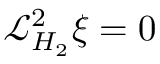Convert formula to latex. <formula><loc_0><loc_0><loc_500><loc_500>\mathcal { L } _ { H _ { 2 } } ^ { 2 } \xi = 0</formula> 